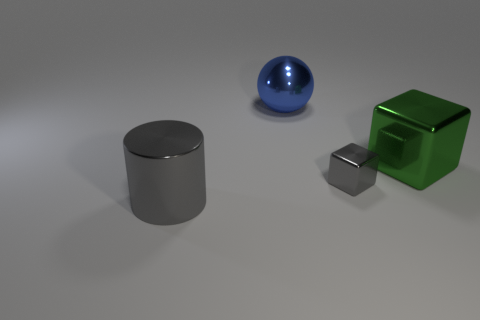Do the thing that is to the right of the gray shiny block and the gray object on the left side of the small metal cube have the same material?
Your answer should be compact. Yes. Are there any other things that are the same material as the small cube?
Your answer should be compact. Yes. There is a metallic object that is in front of the small gray cube; is it the same shape as the gray thing right of the blue ball?
Give a very brief answer. No. Is the number of blocks that are in front of the large green thing less than the number of metallic cylinders?
Offer a terse response. No. How many shiny balls have the same color as the tiny metallic block?
Ensure brevity in your answer.  0. There is a gray shiny object to the left of the big blue metallic object; how big is it?
Offer a terse response. Large. There is a blue thing behind the big shiny object that is to the right of the gray object behind the big gray cylinder; what is its shape?
Provide a succinct answer. Sphere. What shape is the large object that is both in front of the large metal ball and to the right of the large cylinder?
Provide a succinct answer. Cube. Are there any gray shiny blocks of the same size as the green metallic thing?
Offer a very short reply. No. There is a gray thing on the left side of the large blue shiny ball; does it have the same shape as the blue thing?
Offer a terse response. No. 